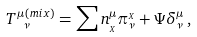Convert formula to latex. <formula><loc_0><loc_0><loc_500><loc_500>T ^ { \mu \, ( m i x ) } _ { \ \nu } = \sum n _ { _ { X } } ^ { \mu } \pi ^ { _ { X } } _ { \nu } + \Psi \delta ^ { \mu } _ { \nu } \, ,</formula> 